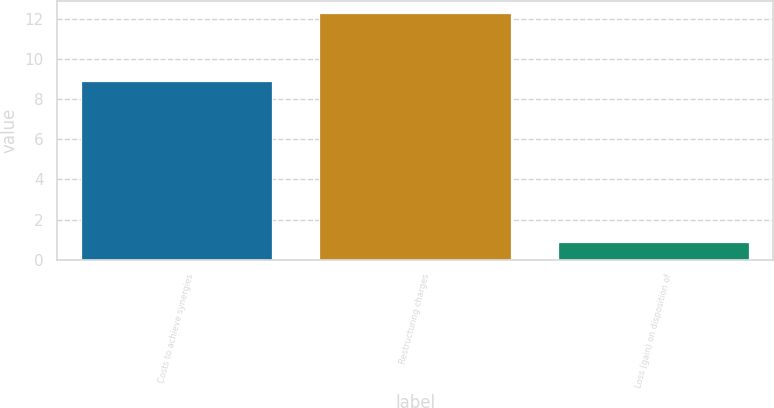Convert chart. <chart><loc_0><loc_0><loc_500><loc_500><bar_chart><fcel>Costs to achieve synergies<fcel>Restructuring charges<fcel>Loss (gain) on disposition of<nl><fcel>8.9<fcel>12.3<fcel>0.9<nl></chart> 